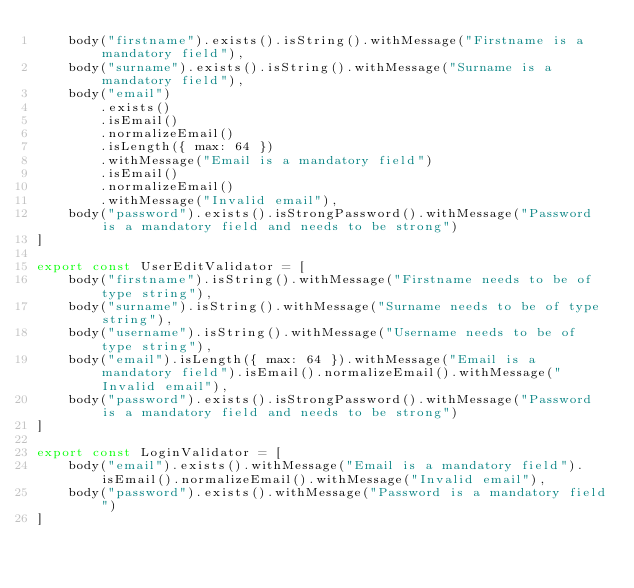Convert code to text. <code><loc_0><loc_0><loc_500><loc_500><_JavaScript_>    body("firstname").exists().isString().withMessage("Firstname is a mandatory field"),
    body("surname").exists().isString().withMessage("Surname is a mandatory field"),
    body("email")
        .exists()
        .isEmail()
        .normalizeEmail()
        .isLength({ max: 64 })
        .withMessage("Email is a mandatory field")
        .isEmail()
        .normalizeEmail()
        .withMessage("Invalid email"),
    body("password").exists().isStrongPassword().withMessage("Password is a mandatory field and needs to be strong")
]

export const UserEditValidator = [
    body("firstname").isString().withMessage("Firstname needs to be of type string"),
    body("surname").isString().withMessage("Surname needs to be of type string"),
    body("username").isString().withMessage("Username needs to be of type string"),
    body("email").isLength({ max: 64 }).withMessage("Email is a mandatory field").isEmail().normalizeEmail().withMessage("Invalid email"),
    body("password").exists().isStrongPassword().withMessage("Password is a mandatory field and needs to be strong")
]

export const LoginValidator = [
    body("email").exists().withMessage("Email is a mandatory field").isEmail().normalizeEmail().withMessage("Invalid email"),
    body("password").exists().withMessage("Password is a mandatory field")
]
</code> 